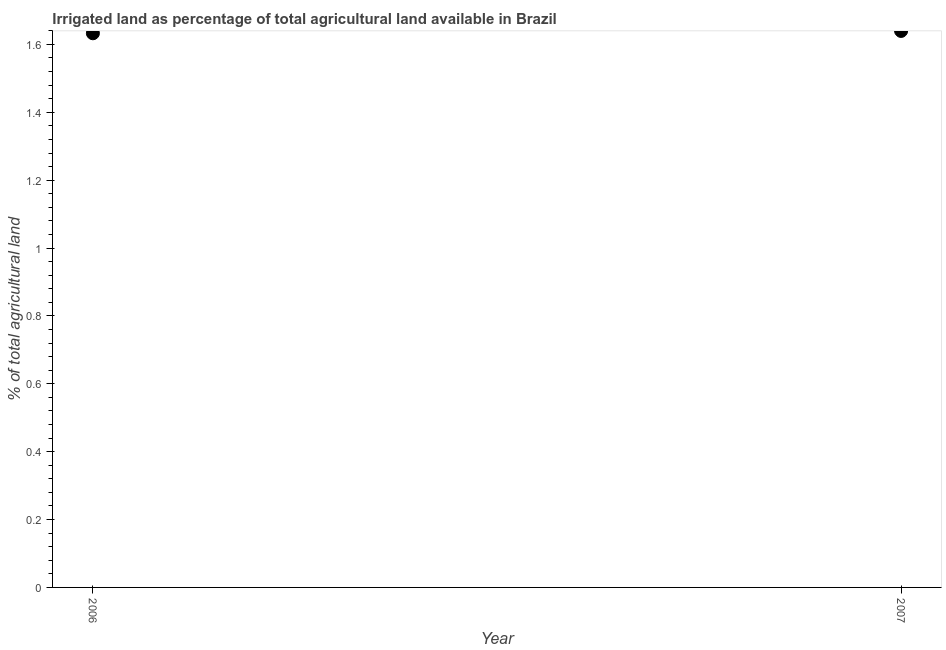What is the percentage of agricultural irrigated land in 2006?
Your answer should be compact. 1.63. Across all years, what is the maximum percentage of agricultural irrigated land?
Provide a short and direct response. 1.64. Across all years, what is the minimum percentage of agricultural irrigated land?
Your response must be concise. 1.63. What is the sum of the percentage of agricultural irrigated land?
Provide a short and direct response. 3.27. What is the difference between the percentage of agricultural irrigated land in 2006 and 2007?
Ensure brevity in your answer.  -0.01. What is the average percentage of agricultural irrigated land per year?
Provide a succinct answer. 1.64. What is the median percentage of agricultural irrigated land?
Your response must be concise. 1.64. Do a majority of the years between 2006 and 2007 (inclusive) have percentage of agricultural irrigated land greater than 0.9600000000000001 %?
Offer a terse response. Yes. What is the ratio of the percentage of agricultural irrigated land in 2006 to that in 2007?
Provide a succinct answer. 1. Is the percentage of agricultural irrigated land in 2006 less than that in 2007?
Your answer should be very brief. Yes. In how many years, is the percentage of agricultural irrigated land greater than the average percentage of agricultural irrigated land taken over all years?
Make the answer very short. 1. Does the percentage of agricultural irrigated land monotonically increase over the years?
Offer a very short reply. Yes. How many dotlines are there?
Offer a very short reply. 1. What is the difference between two consecutive major ticks on the Y-axis?
Make the answer very short. 0.2. Does the graph contain any zero values?
Your response must be concise. No. Does the graph contain grids?
Your response must be concise. No. What is the title of the graph?
Your response must be concise. Irrigated land as percentage of total agricultural land available in Brazil. What is the label or title of the X-axis?
Provide a succinct answer. Year. What is the label or title of the Y-axis?
Keep it short and to the point. % of total agricultural land. What is the % of total agricultural land in 2006?
Provide a succinct answer. 1.63. What is the % of total agricultural land in 2007?
Offer a very short reply. 1.64. What is the difference between the % of total agricultural land in 2006 and 2007?
Ensure brevity in your answer.  -0.01. 